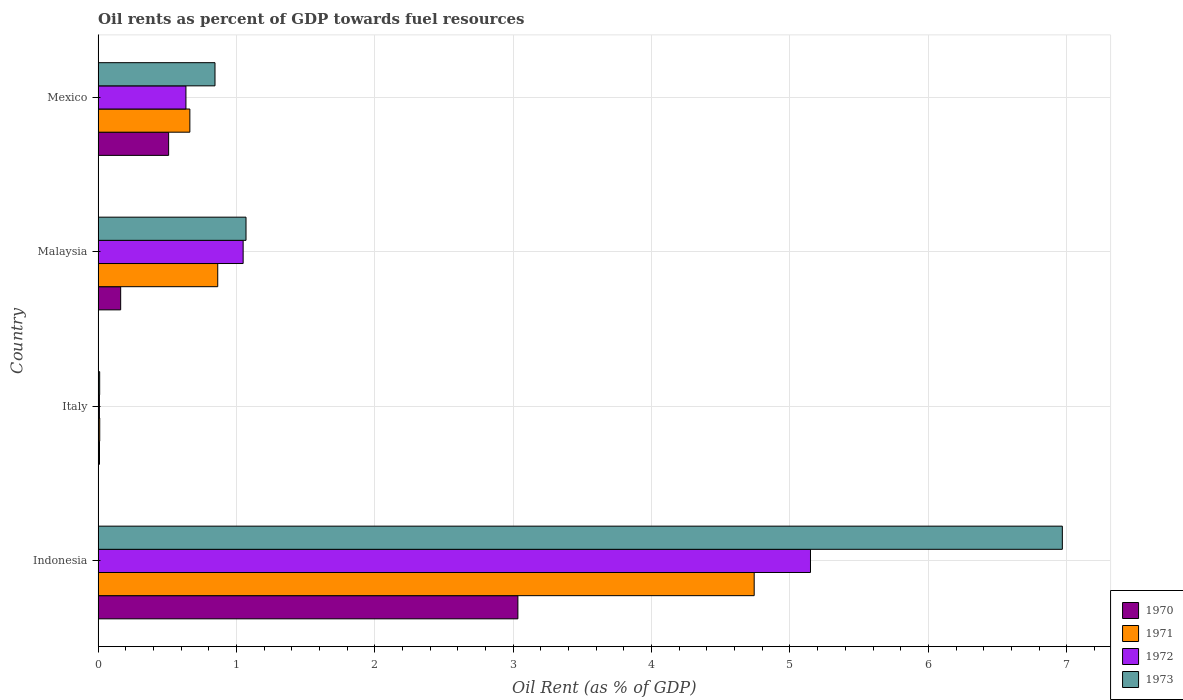How many groups of bars are there?
Your answer should be compact. 4. Are the number of bars per tick equal to the number of legend labels?
Offer a very short reply. Yes. Are the number of bars on each tick of the Y-axis equal?
Your response must be concise. Yes. How many bars are there on the 2nd tick from the bottom?
Make the answer very short. 4. What is the label of the 1st group of bars from the top?
Your answer should be very brief. Mexico. What is the oil rent in 1970 in Malaysia?
Provide a succinct answer. 0.16. Across all countries, what is the maximum oil rent in 1971?
Ensure brevity in your answer.  4.74. Across all countries, what is the minimum oil rent in 1973?
Ensure brevity in your answer.  0.01. In which country was the oil rent in 1970 maximum?
Your answer should be compact. Indonesia. What is the total oil rent in 1970 in the graph?
Offer a terse response. 3.72. What is the difference between the oil rent in 1973 in Italy and that in Malaysia?
Provide a short and direct response. -1.06. What is the difference between the oil rent in 1971 in Malaysia and the oil rent in 1970 in Mexico?
Provide a short and direct response. 0.35. What is the average oil rent in 1971 per country?
Offer a very short reply. 1.57. What is the difference between the oil rent in 1973 and oil rent in 1970 in Mexico?
Your response must be concise. 0.34. What is the ratio of the oil rent in 1972 in Indonesia to that in Malaysia?
Make the answer very short. 4.91. What is the difference between the highest and the second highest oil rent in 1971?
Offer a very short reply. 3.88. What is the difference between the highest and the lowest oil rent in 1973?
Keep it short and to the point. 6.96. In how many countries, is the oil rent in 1972 greater than the average oil rent in 1972 taken over all countries?
Your response must be concise. 1. Is it the case that in every country, the sum of the oil rent in 1970 and oil rent in 1971 is greater than the sum of oil rent in 1973 and oil rent in 1972?
Your response must be concise. No. What does the 2nd bar from the top in Italy represents?
Provide a short and direct response. 1972. Is it the case that in every country, the sum of the oil rent in 1972 and oil rent in 1971 is greater than the oil rent in 1973?
Your answer should be very brief. Yes. How many countries are there in the graph?
Your answer should be compact. 4. Where does the legend appear in the graph?
Provide a succinct answer. Bottom right. What is the title of the graph?
Give a very brief answer. Oil rents as percent of GDP towards fuel resources. Does "2010" appear as one of the legend labels in the graph?
Ensure brevity in your answer.  No. What is the label or title of the X-axis?
Your response must be concise. Oil Rent (as % of GDP). What is the Oil Rent (as % of GDP) of 1970 in Indonesia?
Ensure brevity in your answer.  3.03. What is the Oil Rent (as % of GDP) in 1971 in Indonesia?
Offer a terse response. 4.74. What is the Oil Rent (as % of GDP) in 1972 in Indonesia?
Keep it short and to the point. 5.15. What is the Oil Rent (as % of GDP) in 1973 in Indonesia?
Your answer should be very brief. 6.97. What is the Oil Rent (as % of GDP) of 1970 in Italy?
Give a very brief answer. 0.01. What is the Oil Rent (as % of GDP) in 1971 in Italy?
Keep it short and to the point. 0.01. What is the Oil Rent (as % of GDP) in 1972 in Italy?
Provide a succinct answer. 0.01. What is the Oil Rent (as % of GDP) in 1973 in Italy?
Your response must be concise. 0.01. What is the Oil Rent (as % of GDP) of 1970 in Malaysia?
Provide a succinct answer. 0.16. What is the Oil Rent (as % of GDP) of 1971 in Malaysia?
Give a very brief answer. 0.86. What is the Oil Rent (as % of GDP) in 1972 in Malaysia?
Keep it short and to the point. 1.05. What is the Oil Rent (as % of GDP) in 1973 in Malaysia?
Provide a succinct answer. 1.07. What is the Oil Rent (as % of GDP) of 1970 in Mexico?
Give a very brief answer. 0.51. What is the Oil Rent (as % of GDP) in 1971 in Mexico?
Give a very brief answer. 0.66. What is the Oil Rent (as % of GDP) of 1972 in Mexico?
Ensure brevity in your answer.  0.63. What is the Oil Rent (as % of GDP) in 1973 in Mexico?
Ensure brevity in your answer.  0.84. Across all countries, what is the maximum Oil Rent (as % of GDP) in 1970?
Provide a short and direct response. 3.03. Across all countries, what is the maximum Oil Rent (as % of GDP) of 1971?
Make the answer very short. 4.74. Across all countries, what is the maximum Oil Rent (as % of GDP) in 1972?
Your answer should be compact. 5.15. Across all countries, what is the maximum Oil Rent (as % of GDP) of 1973?
Your answer should be very brief. 6.97. Across all countries, what is the minimum Oil Rent (as % of GDP) in 1970?
Offer a very short reply. 0.01. Across all countries, what is the minimum Oil Rent (as % of GDP) of 1971?
Your answer should be compact. 0.01. Across all countries, what is the minimum Oil Rent (as % of GDP) in 1972?
Your response must be concise. 0.01. Across all countries, what is the minimum Oil Rent (as % of GDP) of 1973?
Provide a short and direct response. 0.01. What is the total Oil Rent (as % of GDP) of 1970 in the graph?
Your answer should be very brief. 3.72. What is the total Oil Rent (as % of GDP) in 1971 in the graph?
Offer a terse response. 6.28. What is the total Oil Rent (as % of GDP) of 1972 in the graph?
Ensure brevity in your answer.  6.84. What is the total Oil Rent (as % of GDP) in 1973 in the graph?
Provide a short and direct response. 8.89. What is the difference between the Oil Rent (as % of GDP) of 1970 in Indonesia and that in Italy?
Provide a short and direct response. 3.02. What is the difference between the Oil Rent (as % of GDP) of 1971 in Indonesia and that in Italy?
Your answer should be very brief. 4.73. What is the difference between the Oil Rent (as % of GDP) in 1972 in Indonesia and that in Italy?
Provide a short and direct response. 5.14. What is the difference between the Oil Rent (as % of GDP) in 1973 in Indonesia and that in Italy?
Your answer should be very brief. 6.96. What is the difference between the Oil Rent (as % of GDP) of 1970 in Indonesia and that in Malaysia?
Your answer should be compact. 2.87. What is the difference between the Oil Rent (as % of GDP) of 1971 in Indonesia and that in Malaysia?
Keep it short and to the point. 3.88. What is the difference between the Oil Rent (as % of GDP) of 1972 in Indonesia and that in Malaysia?
Provide a succinct answer. 4.1. What is the difference between the Oil Rent (as % of GDP) in 1973 in Indonesia and that in Malaysia?
Provide a short and direct response. 5.9. What is the difference between the Oil Rent (as % of GDP) in 1970 in Indonesia and that in Mexico?
Ensure brevity in your answer.  2.52. What is the difference between the Oil Rent (as % of GDP) of 1971 in Indonesia and that in Mexico?
Offer a very short reply. 4.08. What is the difference between the Oil Rent (as % of GDP) of 1972 in Indonesia and that in Mexico?
Your answer should be compact. 4.51. What is the difference between the Oil Rent (as % of GDP) in 1973 in Indonesia and that in Mexico?
Provide a short and direct response. 6.12. What is the difference between the Oil Rent (as % of GDP) of 1970 in Italy and that in Malaysia?
Your answer should be very brief. -0.15. What is the difference between the Oil Rent (as % of GDP) of 1971 in Italy and that in Malaysia?
Offer a terse response. -0.85. What is the difference between the Oil Rent (as % of GDP) of 1972 in Italy and that in Malaysia?
Your answer should be compact. -1.04. What is the difference between the Oil Rent (as % of GDP) in 1973 in Italy and that in Malaysia?
Ensure brevity in your answer.  -1.06. What is the difference between the Oil Rent (as % of GDP) of 1970 in Italy and that in Mexico?
Give a very brief answer. -0.5. What is the difference between the Oil Rent (as % of GDP) of 1971 in Italy and that in Mexico?
Make the answer very short. -0.65. What is the difference between the Oil Rent (as % of GDP) in 1972 in Italy and that in Mexico?
Provide a short and direct response. -0.63. What is the difference between the Oil Rent (as % of GDP) in 1973 in Italy and that in Mexico?
Your answer should be very brief. -0.83. What is the difference between the Oil Rent (as % of GDP) in 1970 in Malaysia and that in Mexico?
Provide a short and direct response. -0.35. What is the difference between the Oil Rent (as % of GDP) in 1971 in Malaysia and that in Mexico?
Provide a short and direct response. 0.2. What is the difference between the Oil Rent (as % of GDP) in 1972 in Malaysia and that in Mexico?
Offer a very short reply. 0.41. What is the difference between the Oil Rent (as % of GDP) in 1973 in Malaysia and that in Mexico?
Offer a terse response. 0.22. What is the difference between the Oil Rent (as % of GDP) of 1970 in Indonesia and the Oil Rent (as % of GDP) of 1971 in Italy?
Your response must be concise. 3.02. What is the difference between the Oil Rent (as % of GDP) in 1970 in Indonesia and the Oil Rent (as % of GDP) in 1972 in Italy?
Offer a very short reply. 3.02. What is the difference between the Oil Rent (as % of GDP) of 1970 in Indonesia and the Oil Rent (as % of GDP) of 1973 in Italy?
Provide a succinct answer. 3.02. What is the difference between the Oil Rent (as % of GDP) in 1971 in Indonesia and the Oil Rent (as % of GDP) in 1972 in Italy?
Your answer should be very brief. 4.73. What is the difference between the Oil Rent (as % of GDP) in 1971 in Indonesia and the Oil Rent (as % of GDP) in 1973 in Italy?
Keep it short and to the point. 4.73. What is the difference between the Oil Rent (as % of GDP) of 1972 in Indonesia and the Oil Rent (as % of GDP) of 1973 in Italy?
Your response must be concise. 5.14. What is the difference between the Oil Rent (as % of GDP) of 1970 in Indonesia and the Oil Rent (as % of GDP) of 1971 in Malaysia?
Offer a very short reply. 2.17. What is the difference between the Oil Rent (as % of GDP) in 1970 in Indonesia and the Oil Rent (as % of GDP) in 1972 in Malaysia?
Your answer should be compact. 1.99. What is the difference between the Oil Rent (as % of GDP) of 1970 in Indonesia and the Oil Rent (as % of GDP) of 1973 in Malaysia?
Your answer should be very brief. 1.96. What is the difference between the Oil Rent (as % of GDP) in 1971 in Indonesia and the Oil Rent (as % of GDP) in 1972 in Malaysia?
Make the answer very short. 3.69. What is the difference between the Oil Rent (as % of GDP) of 1971 in Indonesia and the Oil Rent (as % of GDP) of 1973 in Malaysia?
Your answer should be compact. 3.67. What is the difference between the Oil Rent (as % of GDP) of 1972 in Indonesia and the Oil Rent (as % of GDP) of 1973 in Malaysia?
Your answer should be very brief. 4.08. What is the difference between the Oil Rent (as % of GDP) of 1970 in Indonesia and the Oil Rent (as % of GDP) of 1971 in Mexico?
Keep it short and to the point. 2.37. What is the difference between the Oil Rent (as % of GDP) in 1970 in Indonesia and the Oil Rent (as % of GDP) in 1972 in Mexico?
Your answer should be compact. 2.4. What is the difference between the Oil Rent (as % of GDP) in 1970 in Indonesia and the Oil Rent (as % of GDP) in 1973 in Mexico?
Ensure brevity in your answer.  2.19. What is the difference between the Oil Rent (as % of GDP) in 1971 in Indonesia and the Oil Rent (as % of GDP) in 1972 in Mexico?
Give a very brief answer. 4.11. What is the difference between the Oil Rent (as % of GDP) in 1971 in Indonesia and the Oil Rent (as % of GDP) in 1973 in Mexico?
Offer a very short reply. 3.9. What is the difference between the Oil Rent (as % of GDP) in 1972 in Indonesia and the Oil Rent (as % of GDP) in 1973 in Mexico?
Your response must be concise. 4.3. What is the difference between the Oil Rent (as % of GDP) of 1970 in Italy and the Oil Rent (as % of GDP) of 1971 in Malaysia?
Your answer should be very brief. -0.85. What is the difference between the Oil Rent (as % of GDP) of 1970 in Italy and the Oil Rent (as % of GDP) of 1972 in Malaysia?
Provide a short and direct response. -1.04. What is the difference between the Oil Rent (as % of GDP) in 1970 in Italy and the Oil Rent (as % of GDP) in 1973 in Malaysia?
Give a very brief answer. -1.06. What is the difference between the Oil Rent (as % of GDP) of 1971 in Italy and the Oil Rent (as % of GDP) of 1972 in Malaysia?
Make the answer very short. -1.04. What is the difference between the Oil Rent (as % of GDP) of 1971 in Italy and the Oil Rent (as % of GDP) of 1973 in Malaysia?
Ensure brevity in your answer.  -1.06. What is the difference between the Oil Rent (as % of GDP) in 1972 in Italy and the Oil Rent (as % of GDP) in 1973 in Malaysia?
Give a very brief answer. -1.06. What is the difference between the Oil Rent (as % of GDP) of 1970 in Italy and the Oil Rent (as % of GDP) of 1971 in Mexico?
Provide a short and direct response. -0.65. What is the difference between the Oil Rent (as % of GDP) of 1970 in Italy and the Oil Rent (as % of GDP) of 1972 in Mexico?
Your answer should be compact. -0.62. What is the difference between the Oil Rent (as % of GDP) of 1970 in Italy and the Oil Rent (as % of GDP) of 1973 in Mexico?
Offer a very short reply. -0.83. What is the difference between the Oil Rent (as % of GDP) of 1971 in Italy and the Oil Rent (as % of GDP) of 1972 in Mexico?
Offer a terse response. -0.62. What is the difference between the Oil Rent (as % of GDP) in 1971 in Italy and the Oil Rent (as % of GDP) in 1973 in Mexico?
Your answer should be compact. -0.83. What is the difference between the Oil Rent (as % of GDP) in 1972 in Italy and the Oil Rent (as % of GDP) in 1973 in Mexico?
Provide a succinct answer. -0.84. What is the difference between the Oil Rent (as % of GDP) of 1970 in Malaysia and the Oil Rent (as % of GDP) of 1971 in Mexico?
Provide a short and direct response. -0.5. What is the difference between the Oil Rent (as % of GDP) in 1970 in Malaysia and the Oil Rent (as % of GDP) in 1972 in Mexico?
Ensure brevity in your answer.  -0.47. What is the difference between the Oil Rent (as % of GDP) of 1970 in Malaysia and the Oil Rent (as % of GDP) of 1973 in Mexico?
Keep it short and to the point. -0.68. What is the difference between the Oil Rent (as % of GDP) of 1971 in Malaysia and the Oil Rent (as % of GDP) of 1972 in Mexico?
Give a very brief answer. 0.23. What is the difference between the Oil Rent (as % of GDP) of 1971 in Malaysia and the Oil Rent (as % of GDP) of 1973 in Mexico?
Provide a short and direct response. 0.02. What is the difference between the Oil Rent (as % of GDP) in 1972 in Malaysia and the Oil Rent (as % of GDP) in 1973 in Mexico?
Offer a very short reply. 0.2. What is the average Oil Rent (as % of GDP) in 1970 per country?
Provide a succinct answer. 0.93. What is the average Oil Rent (as % of GDP) in 1971 per country?
Offer a terse response. 1.57. What is the average Oil Rent (as % of GDP) of 1972 per country?
Make the answer very short. 1.71. What is the average Oil Rent (as % of GDP) in 1973 per country?
Your response must be concise. 2.22. What is the difference between the Oil Rent (as % of GDP) in 1970 and Oil Rent (as % of GDP) in 1971 in Indonesia?
Provide a succinct answer. -1.71. What is the difference between the Oil Rent (as % of GDP) in 1970 and Oil Rent (as % of GDP) in 1972 in Indonesia?
Provide a short and direct response. -2.11. What is the difference between the Oil Rent (as % of GDP) in 1970 and Oil Rent (as % of GDP) in 1973 in Indonesia?
Offer a very short reply. -3.93. What is the difference between the Oil Rent (as % of GDP) in 1971 and Oil Rent (as % of GDP) in 1972 in Indonesia?
Provide a succinct answer. -0.41. What is the difference between the Oil Rent (as % of GDP) in 1971 and Oil Rent (as % of GDP) in 1973 in Indonesia?
Keep it short and to the point. -2.23. What is the difference between the Oil Rent (as % of GDP) in 1972 and Oil Rent (as % of GDP) in 1973 in Indonesia?
Your answer should be compact. -1.82. What is the difference between the Oil Rent (as % of GDP) in 1970 and Oil Rent (as % of GDP) in 1971 in Italy?
Offer a very short reply. -0. What is the difference between the Oil Rent (as % of GDP) of 1970 and Oil Rent (as % of GDP) of 1972 in Italy?
Provide a succinct answer. 0. What is the difference between the Oil Rent (as % of GDP) in 1970 and Oil Rent (as % of GDP) in 1973 in Italy?
Keep it short and to the point. -0. What is the difference between the Oil Rent (as % of GDP) in 1971 and Oil Rent (as % of GDP) in 1972 in Italy?
Your answer should be compact. 0. What is the difference between the Oil Rent (as % of GDP) in 1971 and Oil Rent (as % of GDP) in 1973 in Italy?
Your answer should be very brief. 0. What is the difference between the Oil Rent (as % of GDP) in 1972 and Oil Rent (as % of GDP) in 1973 in Italy?
Make the answer very short. -0. What is the difference between the Oil Rent (as % of GDP) in 1970 and Oil Rent (as % of GDP) in 1971 in Malaysia?
Offer a very short reply. -0.7. What is the difference between the Oil Rent (as % of GDP) of 1970 and Oil Rent (as % of GDP) of 1972 in Malaysia?
Provide a short and direct response. -0.89. What is the difference between the Oil Rent (as % of GDP) of 1970 and Oil Rent (as % of GDP) of 1973 in Malaysia?
Your answer should be very brief. -0.91. What is the difference between the Oil Rent (as % of GDP) of 1971 and Oil Rent (as % of GDP) of 1972 in Malaysia?
Give a very brief answer. -0.18. What is the difference between the Oil Rent (as % of GDP) in 1971 and Oil Rent (as % of GDP) in 1973 in Malaysia?
Offer a very short reply. -0.2. What is the difference between the Oil Rent (as % of GDP) of 1972 and Oil Rent (as % of GDP) of 1973 in Malaysia?
Keep it short and to the point. -0.02. What is the difference between the Oil Rent (as % of GDP) of 1970 and Oil Rent (as % of GDP) of 1971 in Mexico?
Your answer should be very brief. -0.15. What is the difference between the Oil Rent (as % of GDP) in 1970 and Oil Rent (as % of GDP) in 1972 in Mexico?
Your response must be concise. -0.13. What is the difference between the Oil Rent (as % of GDP) of 1970 and Oil Rent (as % of GDP) of 1973 in Mexico?
Your response must be concise. -0.34. What is the difference between the Oil Rent (as % of GDP) of 1971 and Oil Rent (as % of GDP) of 1972 in Mexico?
Your answer should be compact. 0.03. What is the difference between the Oil Rent (as % of GDP) of 1971 and Oil Rent (as % of GDP) of 1973 in Mexico?
Provide a short and direct response. -0.18. What is the difference between the Oil Rent (as % of GDP) in 1972 and Oil Rent (as % of GDP) in 1973 in Mexico?
Provide a short and direct response. -0.21. What is the ratio of the Oil Rent (as % of GDP) of 1970 in Indonesia to that in Italy?
Your answer should be very brief. 307.81. What is the ratio of the Oil Rent (as % of GDP) of 1971 in Indonesia to that in Italy?
Give a very brief answer. 404.61. What is the ratio of the Oil Rent (as % of GDP) in 1972 in Indonesia to that in Italy?
Offer a very short reply. 553.4. What is the ratio of the Oil Rent (as % of GDP) of 1973 in Indonesia to that in Italy?
Offer a terse response. 622.04. What is the ratio of the Oil Rent (as % of GDP) in 1970 in Indonesia to that in Malaysia?
Ensure brevity in your answer.  18.61. What is the ratio of the Oil Rent (as % of GDP) in 1971 in Indonesia to that in Malaysia?
Make the answer very short. 5.48. What is the ratio of the Oil Rent (as % of GDP) of 1972 in Indonesia to that in Malaysia?
Your response must be concise. 4.91. What is the ratio of the Oil Rent (as % of GDP) in 1973 in Indonesia to that in Malaysia?
Your answer should be very brief. 6.52. What is the ratio of the Oil Rent (as % of GDP) of 1970 in Indonesia to that in Mexico?
Provide a short and direct response. 5.95. What is the ratio of the Oil Rent (as % of GDP) in 1971 in Indonesia to that in Mexico?
Provide a short and direct response. 7.15. What is the ratio of the Oil Rent (as % of GDP) in 1972 in Indonesia to that in Mexico?
Ensure brevity in your answer.  8.11. What is the ratio of the Oil Rent (as % of GDP) of 1973 in Indonesia to that in Mexico?
Offer a terse response. 8.25. What is the ratio of the Oil Rent (as % of GDP) of 1970 in Italy to that in Malaysia?
Keep it short and to the point. 0.06. What is the ratio of the Oil Rent (as % of GDP) of 1971 in Italy to that in Malaysia?
Make the answer very short. 0.01. What is the ratio of the Oil Rent (as % of GDP) of 1972 in Italy to that in Malaysia?
Offer a very short reply. 0.01. What is the ratio of the Oil Rent (as % of GDP) in 1973 in Italy to that in Malaysia?
Provide a short and direct response. 0.01. What is the ratio of the Oil Rent (as % of GDP) of 1970 in Italy to that in Mexico?
Offer a terse response. 0.02. What is the ratio of the Oil Rent (as % of GDP) of 1971 in Italy to that in Mexico?
Offer a terse response. 0.02. What is the ratio of the Oil Rent (as % of GDP) of 1972 in Italy to that in Mexico?
Provide a short and direct response. 0.01. What is the ratio of the Oil Rent (as % of GDP) in 1973 in Italy to that in Mexico?
Give a very brief answer. 0.01. What is the ratio of the Oil Rent (as % of GDP) of 1970 in Malaysia to that in Mexico?
Offer a terse response. 0.32. What is the ratio of the Oil Rent (as % of GDP) in 1971 in Malaysia to that in Mexico?
Ensure brevity in your answer.  1.3. What is the ratio of the Oil Rent (as % of GDP) of 1972 in Malaysia to that in Mexico?
Ensure brevity in your answer.  1.65. What is the ratio of the Oil Rent (as % of GDP) of 1973 in Malaysia to that in Mexico?
Offer a very short reply. 1.27. What is the difference between the highest and the second highest Oil Rent (as % of GDP) in 1970?
Make the answer very short. 2.52. What is the difference between the highest and the second highest Oil Rent (as % of GDP) of 1971?
Make the answer very short. 3.88. What is the difference between the highest and the second highest Oil Rent (as % of GDP) of 1972?
Give a very brief answer. 4.1. What is the difference between the highest and the second highest Oil Rent (as % of GDP) in 1973?
Your response must be concise. 5.9. What is the difference between the highest and the lowest Oil Rent (as % of GDP) of 1970?
Your answer should be compact. 3.02. What is the difference between the highest and the lowest Oil Rent (as % of GDP) in 1971?
Ensure brevity in your answer.  4.73. What is the difference between the highest and the lowest Oil Rent (as % of GDP) of 1972?
Your answer should be compact. 5.14. What is the difference between the highest and the lowest Oil Rent (as % of GDP) in 1973?
Provide a short and direct response. 6.96. 